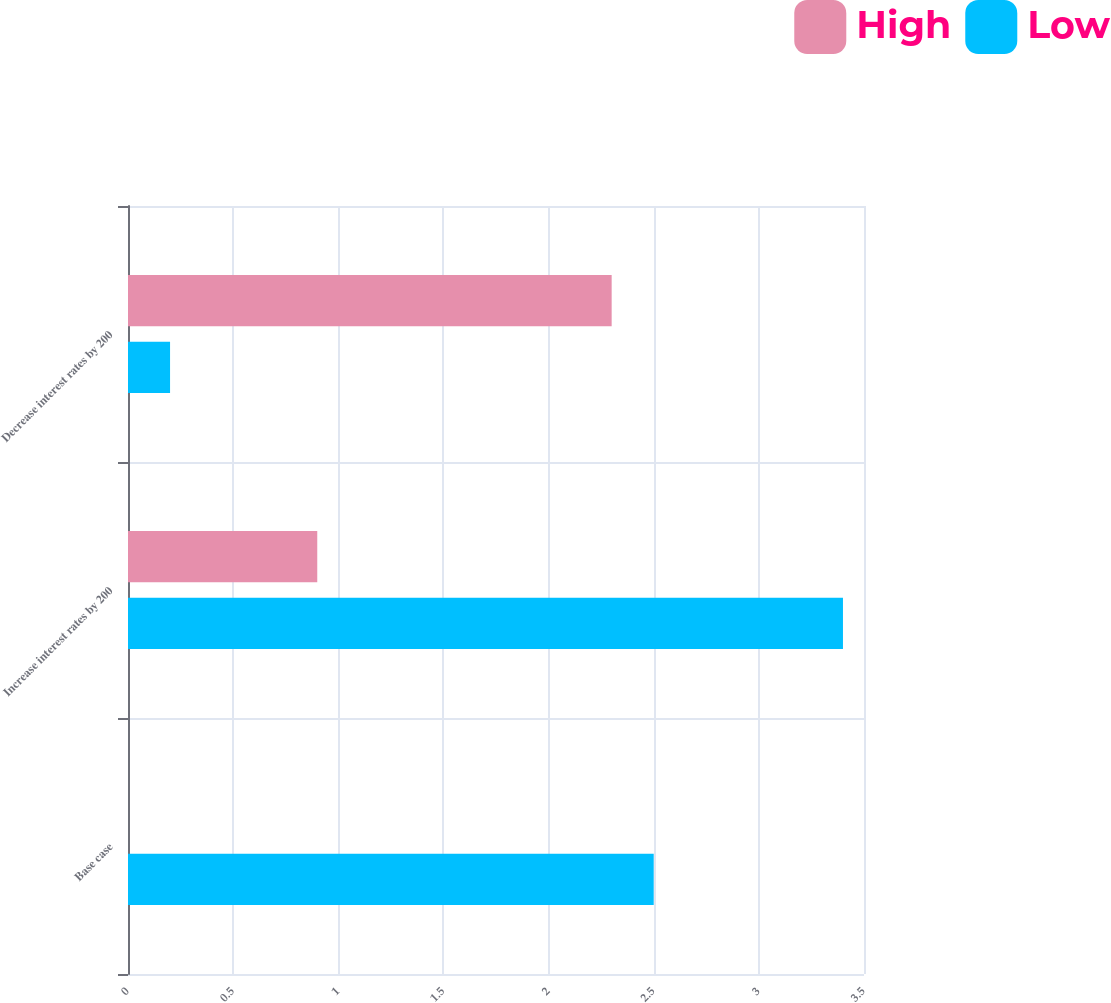Convert chart to OTSL. <chart><loc_0><loc_0><loc_500><loc_500><stacked_bar_chart><ecel><fcel>Base case<fcel>Increase interest rates by 200<fcel>Decrease interest rates by 200<nl><fcel>High<fcel>0<fcel>0.9<fcel>2.3<nl><fcel>Low<fcel>2.5<fcel>3.4<fcel>0.2<nl></chart> 